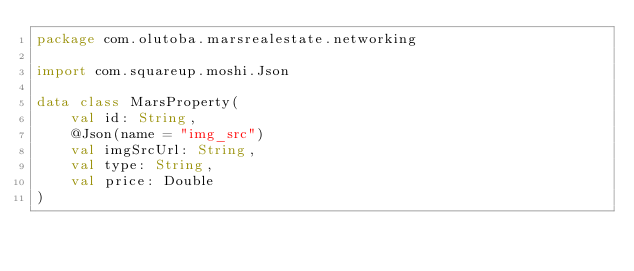Convert code to text. <code><loc_0><loc_0><loc_500><loc_500><_Kotlin_>package com.olutoba.marsrealestate.networking

import com.squareup.moshi.Json

data class MarsProperty(
    val id: String,
    @Json(name = "img_src")
    val imgSrcUrl: String,
    val type: String,
    val price: Double
)</code> 